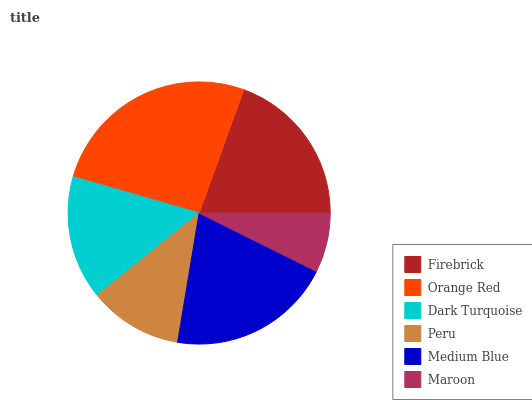Is Maroon the minimum?
Answer yes or no. Yes. Is Orange Red the maximum?
Answer yes or no. Yes. Is Dark Turquoise the minimum?
Answer yes or no. No. Is Dark Turquoise the maximum?
Answer yes or no. No. Is Orange Red greater than Dark Turquoise?
Answer yes or no. Yes. Is Dark Turquoise less than Orange Red?
Answer yes or no. Yes. Is Dark Turquoise greater than Orange Red?
Answer yes or no. No. Is Orange Red less than Dark Turquoise?
Answer yes or no. No. Is Firebrick the high median?
Answer yes or no. Yes. Is Dark Turquoise the low median?
Answer yes or no. Yes. Is Peru the high median?
Answer yes or no. No. Is Peru the low median?
Answer yes or no. No. 